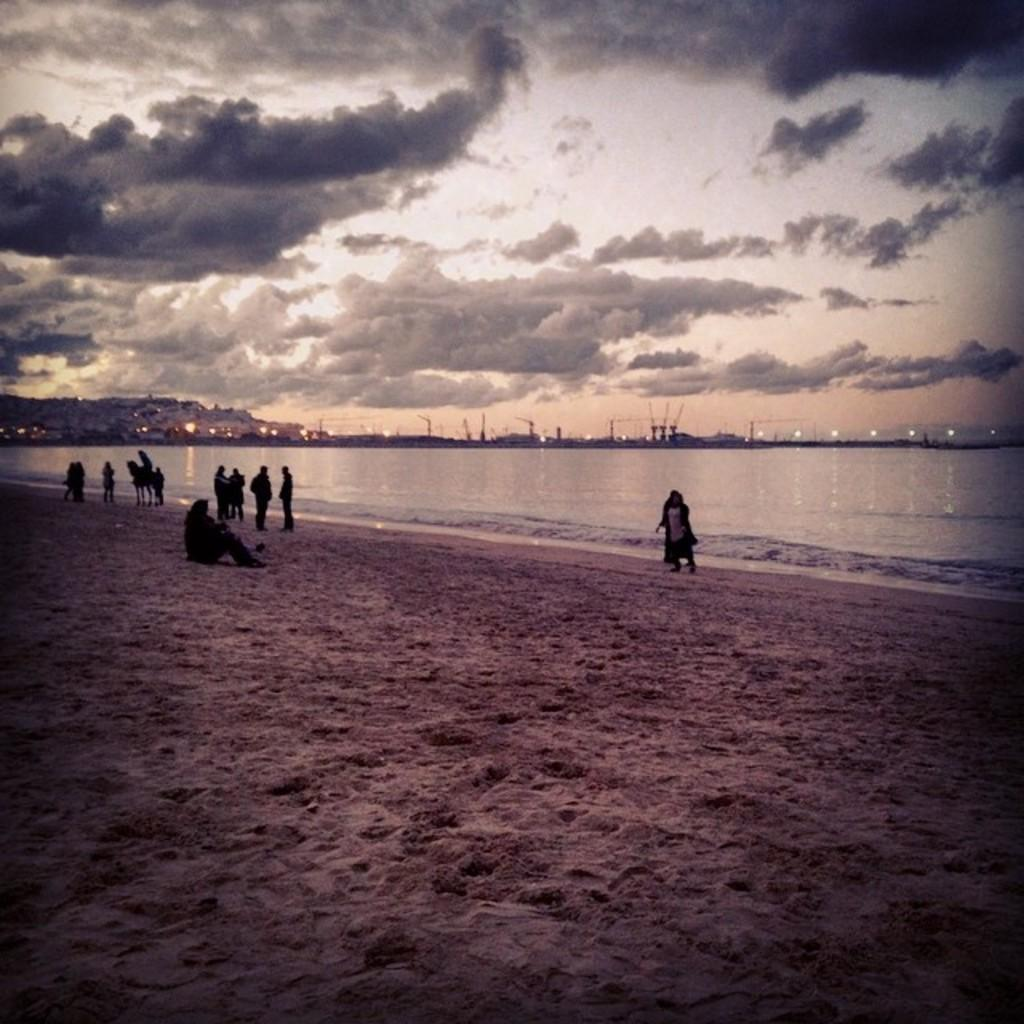Who or what can be seen in the image? There are people in the image. What natural feature is visible in the image? There is water visible in the image. What geographical feature is present in the image? There are mountains in the image. What structures can be seen in the image? There are poles in the image. What additional feature can be seen in the image? There are lights in the image. How would you describe the weather in the image? The sky is cloudy in the image. What type of vein is visible in the image? There is no vein present in the image. Can you see a creature interacting with the poles in the image? A: There is no creature interacting with the poles in the image. 